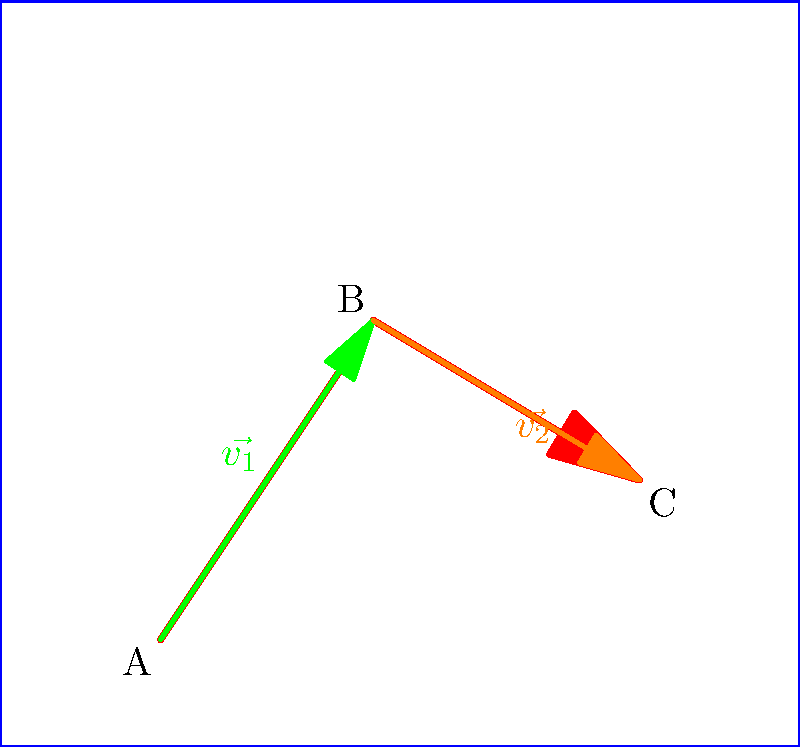A basketball player moves from point A to point B and then to point C on the court as shown in the diagram. The movement is represented by two displacement vectors, $\vec{v_1}$ and $\vec{v_2}$. If $\vec{v_1} = 4\hat{i} + 6\hat{j}$ and $\vec{v_2} = 5\hat{i} - 3\hat{j}$, what is the magnitude of the resultant displacement vector from point A to point C? To find the magnitude of the resultant displacement vector, we need to follow these steps:

1) The resultant displacement vector $\vec{R}$ is the sum of $\vec{v_1}$ and $\vec{v_2}$:
   $\vec{R} = \vec{v_1} + \vec{v_2}$

2) Let's add the vectors component-wise:
   $\vec{R} = (4\hat{i} + 6\hat{j}) + (5\hat{i} - 3\hat{j})$
   $\vec{R} = (4+5)\hat{i} + (6-3)\hat{j}$
   $\vec{R} = 9\hat{i} + 3\hat{j}$

3) Now that we have the components of $\vec{R}$, we can find its magnitude using the Pythagorean theorem:
   $|\vec{R}| = \sqrt{(9)^2 + (3)^2}$

4) Simplify:
   $|\vec{R}| = \sqrt{81 + 9}$
   $|\vec{R}| = \sqrt{90}$

5) Simplify the square root:
   $|\vec{R}| = 3\sqrt{10}$

Therefore, the magnitude of the resultant displacement vector from point A to point C is $3\sqrt{10}$ units.
Answer: $3\sqrt{10}$ units 